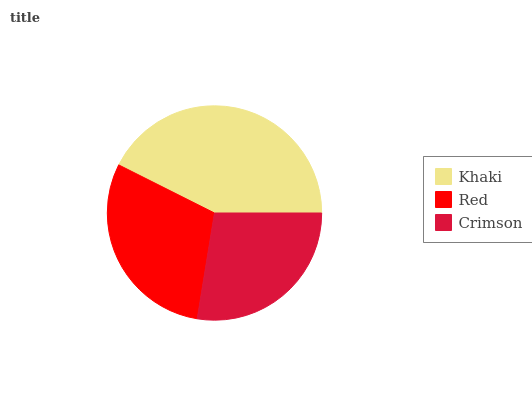Is Crimson the minimum?
Answer yes or no. Yes. Is Khaki the maximum?
Answer yes or no. Yes. Is Red the minimum?
Answer yes or no. No. Is Red the maximum?
Answer yes or no. No. Is Khaki greater than Red?
Answer yes or no. Yes. Is Red less than Khaki?
Answer yes or no. Yes. Is Red greater than Khaki?
Answer yes or no. No. Is Khaki less than Red?
Answer yes or no. No. Is Red the high median?
Answer yes or no. Yes. Is Red the low median?
Answer yes or no. Yes. Is Crimson the high median?
Answer yes or no. No. Is Crimson the low median?
Answer yes or no. No. 